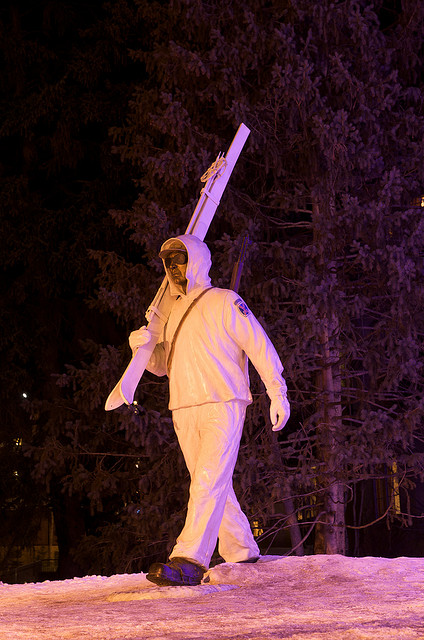<image>Where is this man going? It is unknown where this man is going. However, it seems he might be going skiing. Where is this man going? I don't know where this man is going. It can be skiing or to a lodge. 